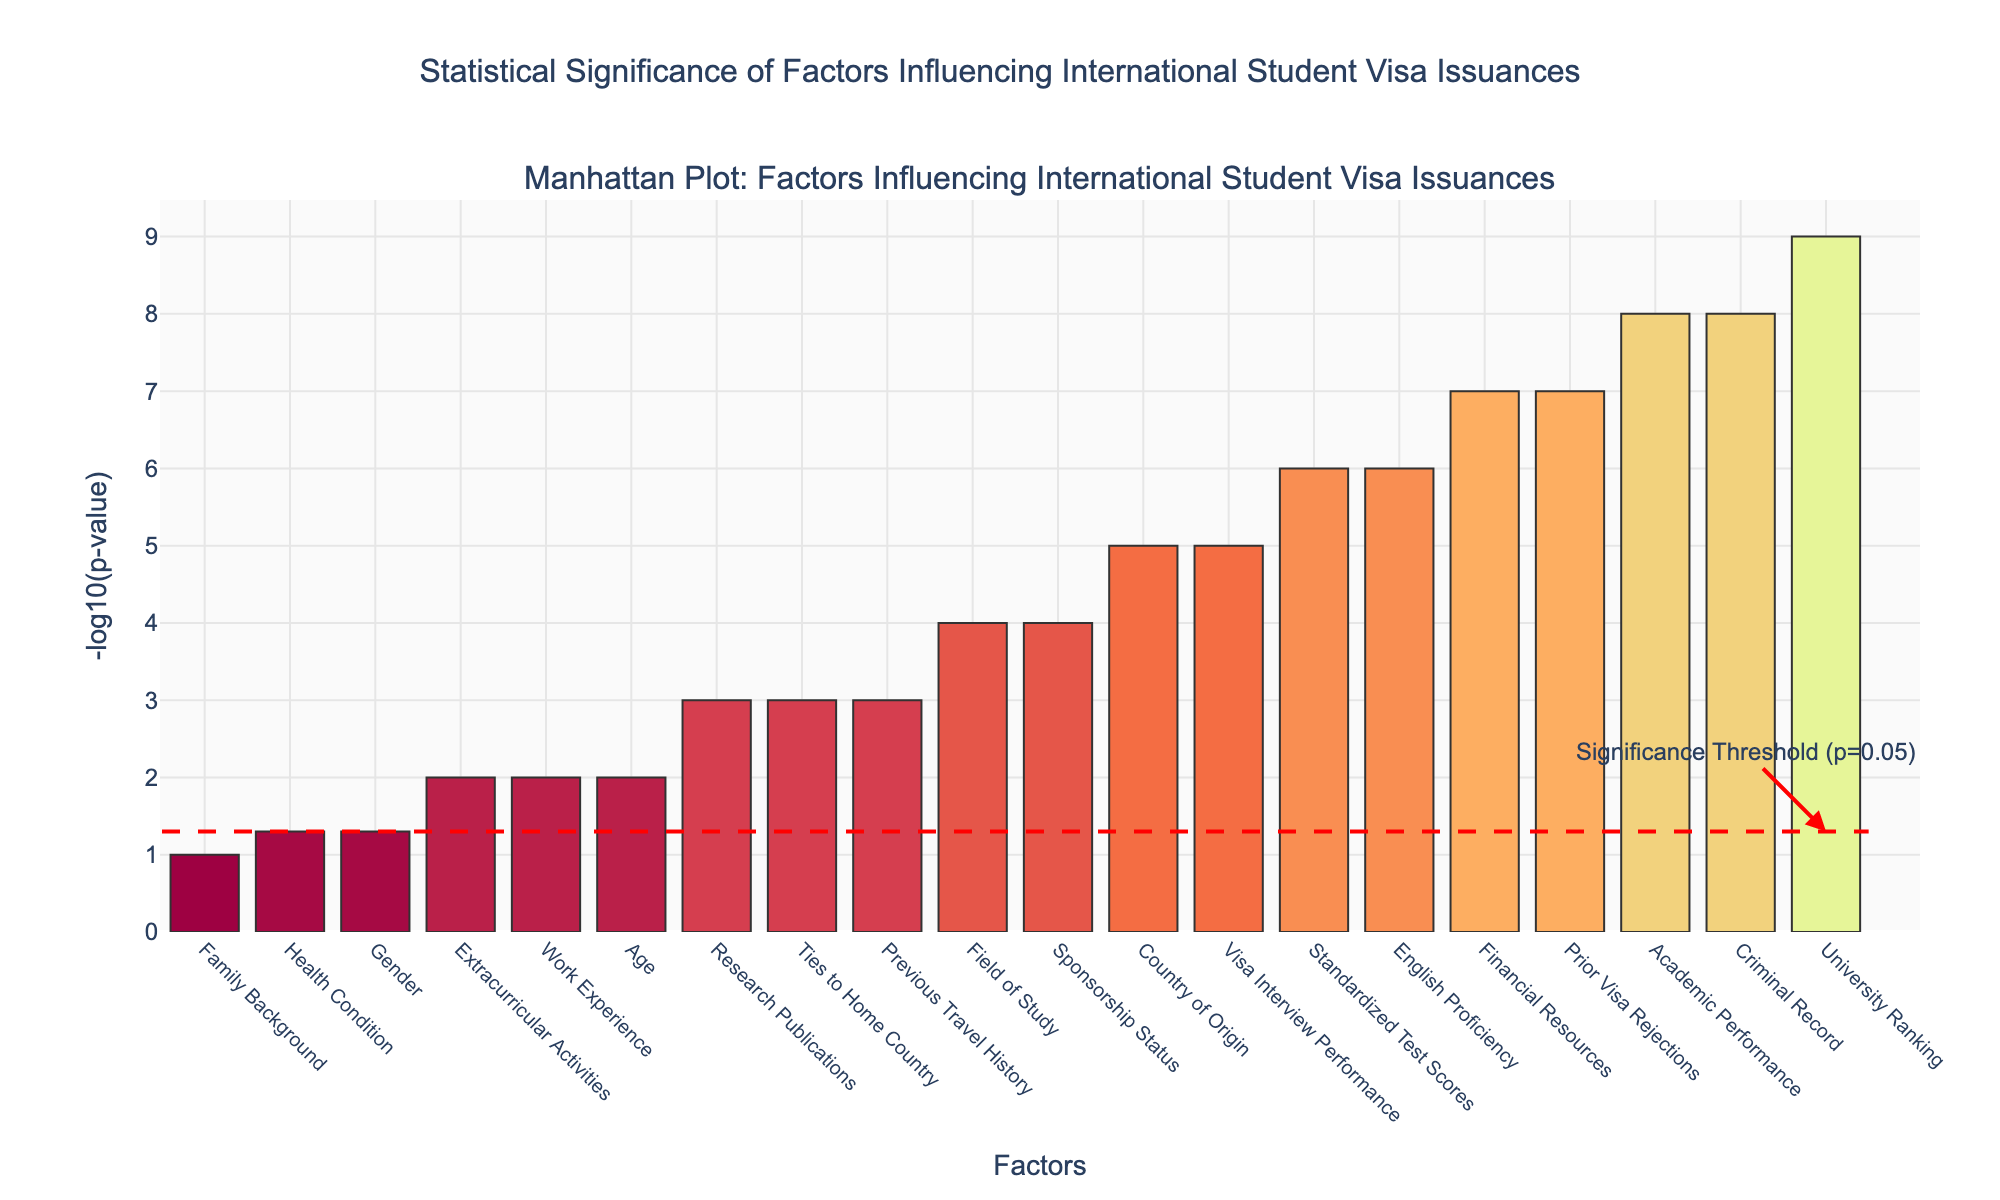What's the title of the plot? The title can be found at the top of the plot. The text in the title box gives an overview of what the plot represents.
Answer: Statistical Significance of Factors Influencing International Student Visa Issuances Which factor has the smallest p-value? The smallest p-value corresponds to the highest -log10(p) value, which can be identified as the tallest bar in the plot.
Answer: University Ranking How many factors have p-values below the significance threshold (p=0.05)? First, convert the p-value threshold to -log10(p) which equals -log10(0.05) ≈ 1.3. Count the number of bars with -log10(p) values above this threshold.
Answer: 15 Which factor has a higher significance, 'English Proficiency' or 'Ties to Home Country'? Compare their heights in the plot. The factor with a taller bar has a lower p-value and hence higher significance.
Answer: English Proficiency How does the significance of 'Academic Performance' compare to 'Criminal Record'? Check the height of the bars for both factors. The taller bar indicates higher significance (lower p-value).
Answer: They have equal significance What is the approximate -log10(p) value for 'Sponsorship Status'? Find the 'Sponsorship Status' bar on the plot and read its height along the y-axis.
Answer: 4 Arrange 'Sponsorship Status', 'Field of Study', and 'Ties to Home Country' in order of their significance, from highest to lowest. Compare their heights in the plot and list them from tallest to shortest.
Answer: Sponsorship Status, Ties to Home Country, Field of Study Which factors have a -log10(p) value close to 3? Examine the heights of the bars and identify any that are near the y-value of 3.
Answer: Previous Travel History, Research Publications What is the color of the bar representing 'Country of Origin'? Locate the 'Country of Origin' bar and describe its color using natural descriptors.
Answer: A shade between orange and red What does a higher bar represent in this plot? Understand the meaning of -log10(p) where a higher value indicates a lower p-value, thus higher statistical significance.
Answer: Lower p-value, higher statistical significance 